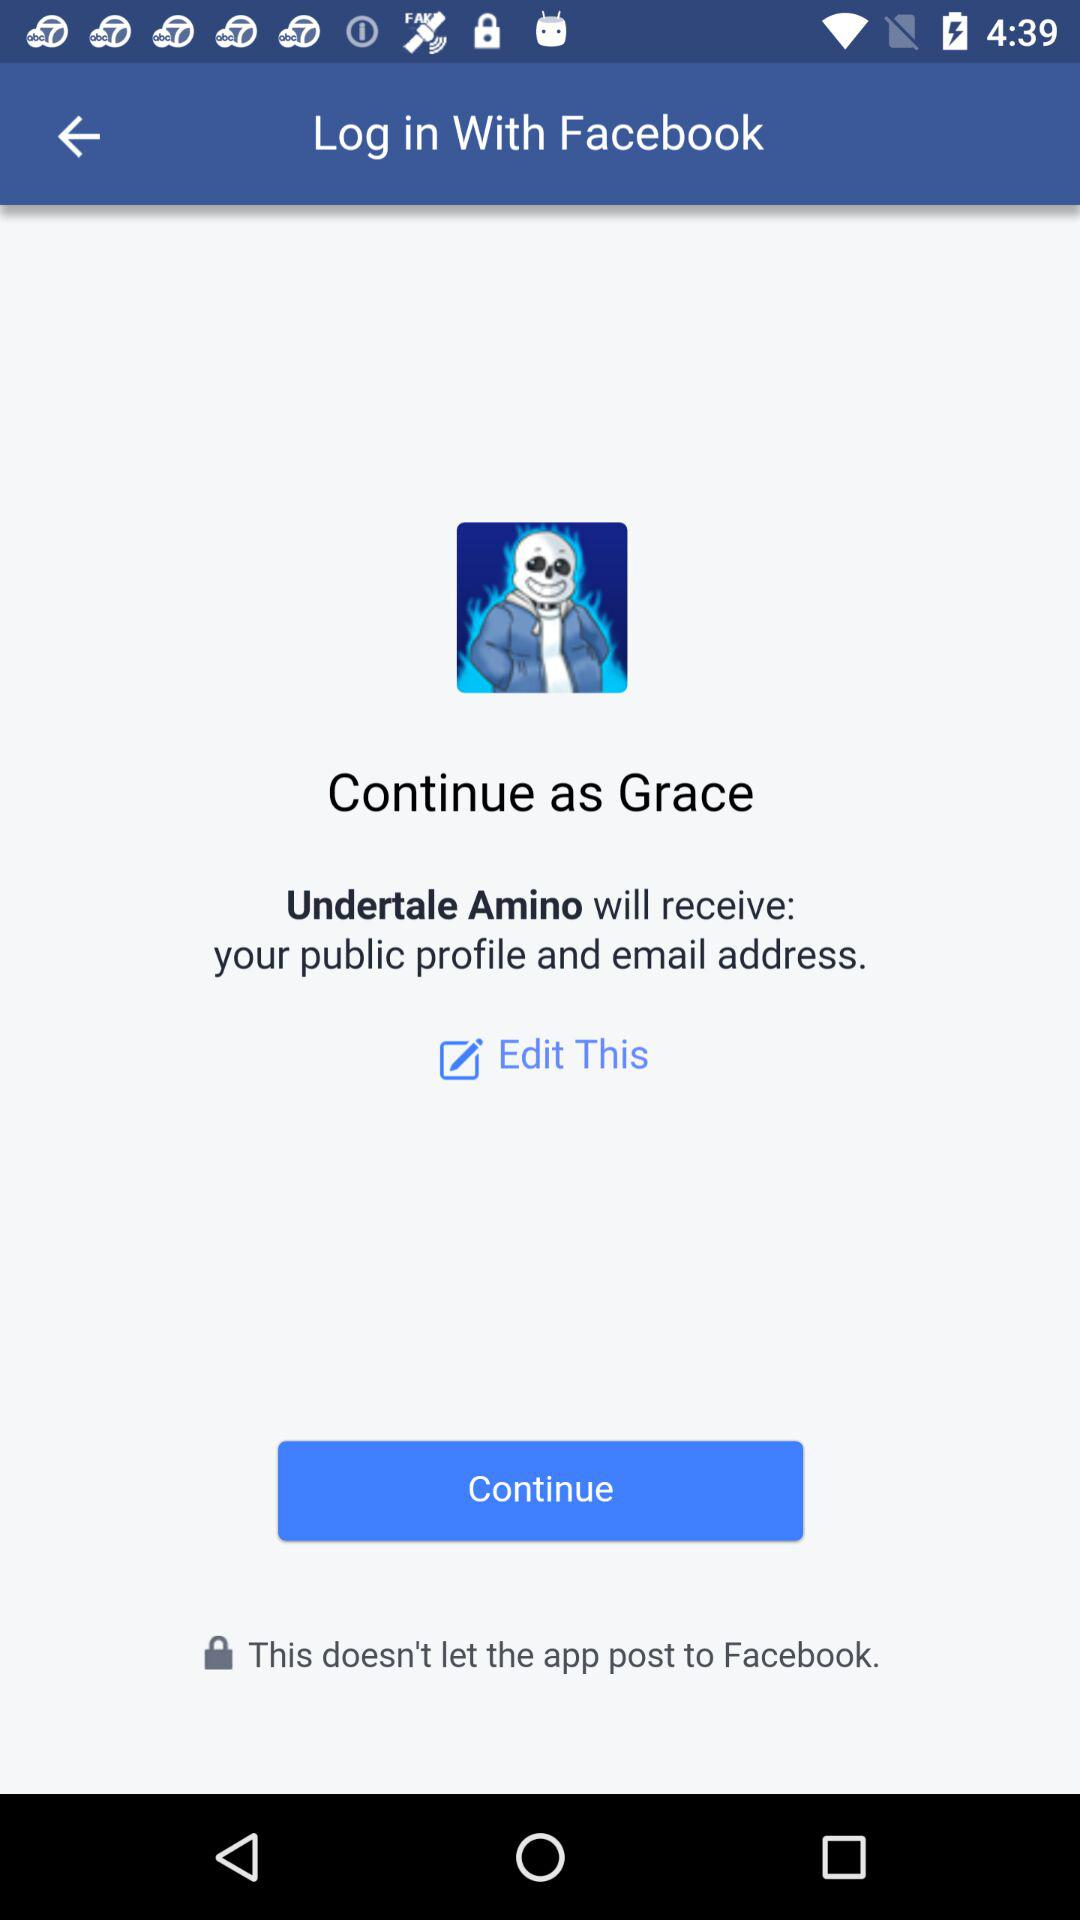What is the name of the user? The name of the user is Grace. 